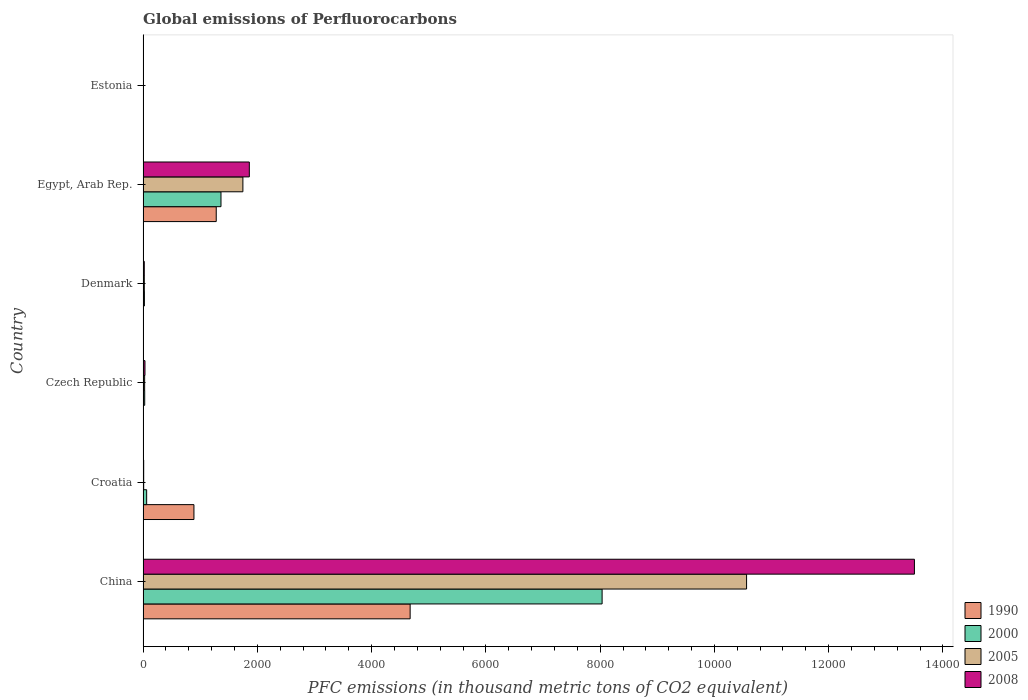How many different coloured bars are there?
Provide a short and direct response. 4. How many groups of bars are there?
Your answer should be compact. 6. Are the number of bars on each tick of the Y-axis equal?
Provide a succinct answer. Yes. How many bars are there on the 1st tick from the bottom?
Make the answer very short. 4. What is the label of the 2nd group of bars from the top?
Keep it short and to the point. Egypt, Arab Rep. What is the global emissions of Perfluorocarbons in 2000 in Czech Republic?
Offer a terse response. 28.8. Across all countries, what is the maximum global emissions of Perfluorocarbons in 2008?
Offer a very short reply. 1.35e+04. In which country was the global emissions of Perfluorocarbons in 1990 maximum?
Your response must be concise. China. In which country was the global emissions of Perfluorocarbons in 2005 minimum?
Keep it short and to the point. Estonia. What is the total global emissions of Perfluorocarbons in 1990 in the graph?
Your answer should be compact. 6850.4. What is the difference between the global emissions of Perfluorocarbons in 2000 in Czech Republic and that in Estonia?
Ensure brevity in your answer.  25.3. What is the difference between the global emissions of Perfluorocarbons in 2005 in Croatia and the global emissions of Perfluorocarbons in 2008 in Estonia?
Ensure brevity in your answer.  7.5. What is the average global emissions of Perfluorocarbons in 1990 per country?
Provide a succinct answer. 1141.73. What is the difference between the global emissions of Perfluorocarbons in 2000 and global emissions of Perfluorocarbons in 2005 in China?
Your response must be concise. -2528.4. What is the ratio of the global emissions of Perfluorocarbons in 2008 in China to that in Croatia?
Offer a terse response. 1227.33. Is the global emissions of Perfluorocarbons in 1990 in China less than that in Egypt, Arab Rep.?
Your answer should be compact. No. What is the difference between the highest and the second highest global emissions of Perfluorocarbons in 2008?
Offer a terse response. 1.16e+04. What is the difference between the highest and the lowest global emissions of Perfluorocarbons in 2005?
Your answer should be very brief. 1.06e+04. Is it the case that in every country, the sum of the global emissions of Perfluorocarbons in 2000 and global emissions of Perfluorocarbons in 2008 is greater than the sum of global emissions of Perfluorocarbons in 1990 and global emissions of Perfluorocarbons in 2005?
Provide a short and direct response. No. What does the 3rd bar from the top in Denmark represents?
Your response must be concise. 2000. Are all the bars in the graph horizontal?
Offer a terse response. Yes. How many legend labels are there?
Make the answer very short. 4. What is the title of the graph?
Your response must be concise. Global emissions of Perfluorocarbons. What is the label or title of the X-axis?
Your response must be concise. PFC emissions (in thousand metric tons of CO2 equivalent). What is the label or title of the Y-axis?
Offer a very short reply. Country. What is the PFC emissions (in thousand metric tons of CO2 equivalent) of 1990 in China?
Your response must be concise. 4674.5. What is the PFC emissions (in thousand metric tons of CO2 equivalent) of 2000 in China?
Provide a short and direct response. 8034.4. What is the PFC emissions (in thousand metric tons of CO2 equivalent) of 2005 in China?
Offer a terse response. 1.06e+04. What is the PFC emissions (in thousand metric tons of CO2 equivalent) of 2008 in China?
Your answer should be very brief. 1.35e+04. What is the PFC emissions (in thousand metric tons of CO2 equivalent) of 1990 in Croatia?
Your response must be concise. 890.4. What is the PFC emissions (in thousand metric tons of CO2 equivalent) of 2005 in Croatia?
Offer a terse response. 10.9. What is the PFC emissions (in thousand metric tons of CO2 equivalent) in 2008 in Croatia?
Offer a terse response. 11. What is the PFC emissions (in thousand metric tons of CO2 equivalent) in 2000 in Czech Republic?
Keep it short and to the point. 28.8. What is the PFC emissions (in thousand metric tons of CO2 equivalent) in 2005 in Czech Republic?
Give a very brief answer. 27.5. What is the PFC emissions (in thousand metric tons of CO2 equivalent) of 2008 in Czech Republic?
Offer a very short reply. 33.3. What is the PFC emissions (in thousand metric tons of CO2 equivalent) of 1990 in Denmark?
Ensure brevity in your answer.  1.4. What is the PFC emissions (in thousand metric tons of CO2 equivalent) of 2000 in Denmark?
Your answer should be compact. 23.4. What is the PFC emissions (in thousand metric tons of CO2 equivalent) in 2008 in Denmark?
Provide a short and direct response. 21.4. What is the PFC emissions (in thousand metric tons of CO2 equivalent) in 1990 in Egypt, Arab Rep.?
Offer a very short reply. 1280.8. What is the PFC emissions (in thousand metric tons of CO2 equivalent) of 2000 in Egypt, Arab Rep.?
Offer a very short reply. 1363.8. What is the PFC emissions (in thousand metric tons of CO2 equivalent) in 2005 in Egypt, Arab Rep.?
Keep it short and to the point. 1747.1. What is the PFC emissions (in thousand metric tons of CO2 equivalent) of 2008 in Egypt, Arab Rep.?
Give a very brief answer. 1859.8. What is the PFC emissions (in thousand metric tons of CO2 equivalent) of 2008 in Estonia?
Your answer should be compact. 3.4. Across all countries, what is the maximum PFC emissions (in thousand metric tons of CO2 equivalent) of 1990?
Offer a very short reply. 4674.5. Across all countries, what is the maximum PFC emissions (in thousand metric tons of CO2 equivalent) in 2000?
Your answer should be very brief. 8034.4. Across all countries, what is the maximum PFC emissions (in thousand metric tons of CO2 equivalent) in 2005?
Keep it short and to the point. 1.06e+04. Across all countries, what is the maximum PFC emissions (in thousand metric tons of CO2 equivalent) of 2008?
Keep it short and to the point. 1.35e+04. Across all countries, what is the minimum PFC emissions (in thousand metric tons of CO2 equivalent) of 1990?
Provide a succinct answer. 0.5. Across all countries, what is the minimum PFC emissions (in thousand metric tons of CO2 equivalent) in 2000?
Make the answer very short. 3.5. Across all countries, what is the minimum PFC emissions (in thousand metric tons of CO2 equivalent) in 2005?
Your response must be concise. 3.4. Across all countries, what is the minimum PFC emissions (in thousand metric tons of CO2 equivalent) of 2008?
Provide a succinct answer. 3.4. What is the total PFC emissions (in thousand metric tons of CO2 equivalent) of 1990 in the graph?
Keep it short and to the point. 6850.4. What is the total PFC emissions (in thousand metric tons of CO2 equivalent) in 2000 in the graph?
Make the answer very short. 9516.9. What is the total PFC emissions (in thousand metric tons of CO2 equivalent) of 2005 in the graph?
Keep it short and to the point. 1.24e+04. What is the total PFC emissions (in thousand metric tons of CO2 equivalent) in 2008 in the graph?
Provide a short and direct response. 1.54e+04. What is the difference between the PFC emissions (in thousand metric tons of CO2 equivalent) in 1990 in China and that in Croatia?
Ensure brevity in your answer.  3784.1. What is the difference between the PFC emissions (in thousand metric tons of CO2 equivalent) in 2000 in China and that in Croatia?
Keep it short and to the point. 7971.4. What is the difference between the PFC emissions (in thousand metric tons of CO2 equivalent) of 2005 in China and that in Croatia?
Offer a terse response. 1.06e+04. What is the difference between the PFC emissions (in thousand metric tons of CO2 equivalent) of 2008 in China and that in Croatia?
Ensure brevity in your answer.  1.35e+04. What is the difference between the PFC emissions (in thousand metric tons of CO2 equivalent) of 1990 in China and that in Czech Republic?
Offer a terse response. 4671.7. What is the difference between the PFC emissions (in thousand metric tons of CO2 equivalent) in 2000 in China and that in Czech Republic?
Provide a succinct answer. 8005.6. What is the difference between the PFC emissions (in thousand metric tons of CO2 equivalent) of 2005 in China and that in Czech Republic?
Your answer should be compact. 1.05e+04. What is the difference between the PFC emissions (in thousand metric tons of CO2 equivalent) of 2008 in China and that in Czech Republic?
Make the answer very short. 1.35e+04. What is the difference between the PFC emissions (in thousand metric tons of CO2 equivalent) in 1990 in China and that in Denmark?
Provide a short and direct response. 4673.1. What is the difference between the PFC emissions (in thousand metric tons of CO2 equivalent) in 2000 in China and that in Denmark?
Your answer should be compact. 8011. What is the difference between the PFC emissions (in thousand metric tons of CO2 equivalent) in 2005 in China and that in Denmark?
Make the answer very short. 1.05e+04. What is the difference between the PFC emissions (in thousand metric tons of CO2 equivalent) in 2008 in China and that in Denmark?
Your response must be concise. 1.35e+04. What is the difference between the PFC emissions (in thousand metric tons of CO2 equivalent) of 1990 in China and that in Egypt, Arab Rep.?
Your answer should be very brief. 3393.7. What is the difference between the PFC emissions (in thousand metric tons of CO2 equivalent) of 2000 in China and that in Egypt, Arab Rep.?
Give a very brief answer. 6670.6. What is the difference between the PFC emissions (in thousand metric tons of CO2 equivalent) of 2005 in China and that in Egypt, Arab Rep.?
Keep it short and to the point. 8815.7. What is the difference between the PFC emissions (in thousand metric tons of CO2 equivalent) in 2008 in China and that in Egypt, Arab Rep.?
Make the answer very short. 1.16e+04. What is the difference between the PFC emissions (in thousand metric tons of CO2 equivalent) in 1990 in China and that in Estonia?
Your response must be concise. 4674. What is the difference between the PFC emissions (in thousand metric tons of CO2 equivalent) of 2000 in China and that in Estonia?
Provide a short and direct response. 8030.9. What is the difference between the PFC emissions (in thousand metric tons of CO2 equivalent) of 2005 in China and that in Estonia?
Offer a terse response. 1.06e+04. What is the difference between the PFC emissions (in thousand metric tons of CO2 equivalent) in 2008 in China and that in Estonia?
Your response must be concise. 1.35e+04. What is the difference between the PFC emissions (in thousand metric tons of CO2 equivalent) of 1990 in Croatia and that in Czech Republic?
Your answer should be very brief. 887.6. What is the difference between the PFC emissions (in thousand metric tons of CO2 equivalent) of 2000 in Croatia and that in Czech Republic?
Make the answer very short. 34.2. What is the difference between the PFC emissions (in thousand metric tons of CO2 equivalent) in 2005 in Croatia and that in Czech Republic?
Provide a succinct answer. -16.6. What is the difference between the PFC emissions (in thousand metric tons of CO2 equivalent) of 2008 in Croatia and that in Czech Republic?
Provide a short and direct response. -22.3. What is the difference between the PFC emissions (in thousand metric tons of CO2 equivalent) of 1990 in Croatia and that in Denmark?
Offer a very short reply. 889. What is the difference between the PFC emissions (in thousand metric tons of CO2 equivalent) of 2000 in Croatia and that in Denmark?
Provide a succinct answer. 39.6. What is the difference between the PFC emissions (in thousand metric tons of CO2 equivalent) of 1990 in Croatia and that in Egypt, Arab Rep.?
Your answer should be compact. -390.4. What is the difference between the PFC emissions (in thousand metric tons of CO2 equivalent) in 2000 in Croatia and that in Egypt, Arab Rep.?
Offer a very short reply. -1300.8. What is the difference between the PFC emissions (in thousand metric tons of CO2 equivalent) in 2005 in Croatia and that in Egypt, Arab Rep.?
Offer a terse response. -1736.2. What is the difference between the PFC emissions (in thousand metric tons of CO2 equivalent) in 2008 in Croatia and that in Egypt, Arab Rep.?
Make the answer very short. -1848.8. What is the difference between the PFC emissions (in thousand metric tons of CO2 equivalent) of 1990 in Croatia and that in Estonia?
Your answer should be very brief. 889.9. What is the difference between the PFC emissions (in thousand metric tons of CO2 equivalent) in 2000 in Croatia and that in Estonia?
Your answer should be compact. 59.5. What is the difference between the PFC emissions (in thousand metric tons of CO2 equivalent) of 2000 in Czech Republic and that in Denmark?
Keep it short and to the point. 5.4. What is the difference between the PFC emissions (in thousand metric tons of CO2 equivalent) of 2005 in Czech Republic and that in Denmark?
Your response must be concise. 6. What is the difference between the PFC emissions (in thousand metric tons of CO2 equivalent) in 2008 in Czech Republic and that in Denmark?
Offer a very short reply. 11.9. What is the difference between the PFC emissions (in thousand metric tons of CO2 equivalent) of 1990 in Czech Republic and that in Egypt, Arab Rep.?
Offer a terse response. -1278. What is the difference between the PFC emissions (in thousand metric tons of CO2 equivalent) in 2000 in Czech Republic and that in Egypt, Arab Rep.?
Your answer should be compact. -1335. What is the difference between the PFC emissions (in thousand metric tons of CO2 equivalent) in 2005 in Czech Republic and that in Egypt, Arab Rep.?
Ensure brevity in your answer.  -1719.6. What is the difference between the PFC emissions (in thousand metric tons of CO2 equivalent) in 2008 in Czech Republic and that in Egypt, Arab Rep.?
Ensure brevity in your answer.  -1826.5. What is the difference between the PFC emissions (in thousand metric tons of CO2 equivalent) in 1990 in Czech Republic and that in Estonia?
Your answer should be compact. 2.3. What is the difference between the PFC emissions (in thousand metric tons of CO2 equivalent) in 2000 in Czech Republic and that in Estonia?
Give a very brief answer. 25.3. What is the difference between the PFC emissions (in thousand metric tons of CO2 equivalent) in 2005 in Czech Republic and that in Estonia?
Provide a succinct answer. 24.1. What is the difference between the PFC emissions (in thousand metric tons of CO2 equivalent) in 2008 in Czech Republic and that in Estonia?
Offer a terse response. 29.9. What is the difference between the PFC emissions (in thousand metric tons of CO2 equivalent) in 1990 in Denmark and that in Egypt, Arab Rep.?
Provide a short and direct response. -1279.4. What is the difference between the PFC emissions (in thousand metric tons of CO2 equivalent) in 2000 in Denmark and that in Egypt, Arab Rep.?
Keep it short and to the point. -1340.4. What is the difference between the PFC emissions (in thousand metric tons of CO2 equivalent) in 2005 in Denmark and that in Egypt, Arab Rep.?
Your answer should be compact. -1725.6. What is the difference between the PFC emissions (in thousand metric tons of CO2 equivalent) in 2008 in Denmark and that in Egypt, Arab Rep.?
Make the answer very short. -1838.4. What is the difference between the PFC emissions (in thousand metric tons of CO2 equivalent) of 2005 in Denmark and that in Estonia?
Give a very brief answer. 18.1. What is the difference between the PFC emissions (in thousand metric tons of CO2 equivalent) in 1990 in Egypt, Arab Rep. and that in Estonia?
Provide a succinct answer. 1280.3. What is the difference between the PFC emissions (in thousand metric tons of CO2 equivalent) of 2000 in Egypt, Arab Rep. and that in Estonia?
Offer a very short reply. 1360.3. What is the difference between the PFC emissions (in thousand metric tons of CO2 equivalent) of 2005 in Egypt, Arab Rep. and that in Estonia?
Provide a succinct answer. 1743.7. What is the difference between the PFC emissions (in thousand metric tons of CO2 equivalent) in 2008 in Egypt, Arab Rep. and that in Estonia?
Ensure brevity in your answer.  1856.4. What is the difference between the PFC emissions (in thousand metric tons of CO2 equivalent) in 1990 in China and the PFC emissions (in thousand metric tons of CO2 equivalent) in 2000 in Croatia?
Offer a very short reply. 4611.5. What is the difference between the PFC emissions (in thousand metric tons of CO2 equivalent) in 1990 in China and the PFC emissions (in thousand metric tons of CO2 equivalent) in 2005 in Croatia?
Your response must be concise. 4663.6. What is the difference between the PFC emissions (in thousand metric tons of CO2 equivalent) of 1990 in China and the PFC emissions (in thousand metric tons of CO2 equivalent) of 2008 in Croatia?
Offer a terse response. 4663.5. What is the difference between the PFC emissions (in thousand metric tons of CO2 equivalent) in 2000 in China and the PFC emissions (in thousand metric tons of CO2 equivalent) in 2005 in Croatia?
Offer a very short reply. 8023.5. What is the difference between the PFC emissions (in thousand metric tons of CO2 equivalent) of 2000 in China and the PFC emissions (in thousand metric tons of CO2 equivalent) of 2008 in Croatia?
Provide a succinct answer. 8023.4. What is the difference between the PFC emissions (in thousand metric tons of CO2 equivalent) of 2005 in China and the PFC emissions (in thousand metric tons of CO2 equivalent) of 2008 in Croatia?
Your answer should be very brief. 1.06e+04. What is the difference between the PFC emissions (in thousand metric tons of CO2 equivalent) in 1990 in China and the PFC emissions (in thousand metric tons of CO2 equivalent) in 2000 in Czech Republic?
Your answer should be compact. 4645.7. What is the difference between the PFC emissions (in thousand metric tons of CO2 equivalent) in 1990 in China and the PFC emissions (in thousand metric tons of CO2 equivalent) in 2005 in Czech Republic?
Your response must be concise. 4647. What is the difference between the PFC emissions (in thousand metric tons of CO2 equivalent) of 1990 in China and the PFC emissions (in thousand metric tons of CO2 equivalent) of 2008 in Czech Republic?
Your answer should be very brief. 4641.2. What is the difference between the PFC emissions (in thousand metric tons of CO2 equivalent) of 2000 in China and the PFC emissions (in thousand metric tons of CO2 equivalent) of 2005 in Czech Republic?
Offer a very short reply. 8006.9. What is the difference between the PFC emissions (in thousand metric tons of CO2 equivalent) of 2000 in China and the PFC emissions (in thousand metric tons of CO2 equivalent) of 2008 in Czech Republic?
Ensure brevity in your answer.  8001.1. What is the difference between the PFC emissions (in thousand metric tons of CO2 equivalent) in 2005 in China and the PFC emissions (in thousand metric tons of CO2 equivalent) in 2008 in Czech Republic?
Ensure brevity in your answer.  1.05e+04. What is the difference between the PFC emissions (in thousand metric tons of CO2 equivalent) in 1990 in China and the PFC emissions (in thousand metric tons of CO2 equivalent) in 2000 in Denmark?
Keep it short and to the point. 4651.1. What is the difference between the PFC emissions (in thousand metric tons of CO2 equivalent) in 1990 in China and the PFC emissions (in thousand metric tons of CO2 equivalent) in 2005 in Denmark?
Provide a succinct answer. 4653. What is the difference between the PFC emissions (in thousand metric tons of CO2 equivalent) in 1990 in China and the PFC emissions (in thousand metric tons of CO2 equivalent) in 2008 in Denmark?
Your answer should be very brief. 4653.1. What is the difference between the PFC emissions (in thousand metric tons of CO2 equivalent) in 2000 in China and the PFC emissions (in thousand metric tons of CO2 equivalent) in 2005 in Denmark?
Ensure brevity in your answer.  8012.9. What is the difference between the PFC emissions (in thousand metric tons of CO2 equivalent) of 2000 in China and the PFC emissions (in thousand metric tons of CO2 equivalent) of 2008 in Denmark?
Provide a succinct answer. 8013. What is the difference between the PFC emissions (in thousand metric tons of CO2 equivalent) of 2005 in China and the PFC emissions (in thousand metric tons of CO2 equivalent) of 2008 in Denmark?
Keep it short and to the point. 1.05e+04. What is the difference between the PFC emissions (in thousand metric tons of CO2 equivalent) in 1990 in China and the PFC emissions (in thousand metric tons of CO2 equivalent) in 2000 in Egypt, Arab Rep.?
Offer a terse response. 3310.7. What is the difference between the PFC emissions (in thousand metric tons of CO2 equivalent) in 1990 in China and the PFC emissions (in thousand metric tons of CO2 equivalent) in 2005 in Egypt, Arab Rep.?
Ensure brevity in your answer.  2927.4. What is the difference between the PFC emissions (in thousand metric tons of CO2 equivalent) in 1990 in China and the PFC emissions (in thousand metric tons of CO2 equivalent) in 2008 in Egypt, Arab Rep.?
Provide a succinct answer. 2814.7. What is the difference between the PFC emissions (in thousand metric tons of CO2 equivalent) of 2000 in China and the PFC emissions (in thousand metric tons of CO2 equivalent) of 2005 in Egypt, Arab Rep.?
Provide a short and direct response. 6287.3. What is the difference between the PFC emissions (in thousand metric tons of CO2 equivalent) in 2000 in China and the PFC emissions (in thousand metric tons of CO2 equivalent) in 2008 in Egypt, Arab Rep.?
Provide a short and direct response. 6174.6. What is the difference between the PFC emissions (in thousand metric tons of CO2 equivalent) in 2005 in China and the PFC emissions (in thousand metric tons of CO2 equivalent) in 2008 in Egypt, Arab Rep.?
Offer a terse response. 8703. What is the difference between the PFC emissions (in thousand metric tons of CO2 equivalent) in 1990 in China and the PFC emissions (in thousand metric tons of CO2 equivalent) in 2000 in Estonia?
Provide a short and direct response. 4671. What is the difference between the PFC emissions (in thousand metric tons of CO2 equivalent) of 1990 in China and the PFC emissions (in thousand metric tons of CO2 equivalent) of 2005 in Estonia?
Make the answer very short. 4671.1. What is the difference between the PFC emissions (in thousand metric tons of CO2 equivalent) of 1990 in China and the PFC emissions (in thousand metric tons of CO2 equivalent) of 2008 in Estonia?
Your answer should be compact. 4671.1. What is the difference between the PFC emissions (in thousand metric tons of CO2 equivalent) of 2000 in China and the PFC emissions (in thousand metric tons of CO2 equivalent) of 2005 in Estonia?
Keep it short and to the point. 8031. What is the difference between the PFC emissions (in thousand metric tons of CO2 equivalent) of 2000 in China and the PFC emissions (in thousand metric tons of CO2 equivalent) of 2008 in Estonia?
Make the answer very short. 8031. What is the difference between the PFC emissions (in thousand metric tons of CO2 equivalent) of 2005 in China and the PFC emissions (in thousand metric tons of CO2 equivalent) of 2008 in Estonia?
Keep it short and to the point. 1.06e+04. What is the difference between the PFC emissions (in thousand metric tons of CO2 equivalent) in 1990 in Croatia and the PFC emissions (in thousand metric tons of CO2 equivalent) in 2000 in Czech Republic?
Keep it short and to the point. 861.6. What is the difference between the PFC emissions (in thousand metric tons of CO2 equivalent) of 1990 in Croatia and the PFC emissions (in thousand metric tons of CO2 equivalent) of 2005 in Czech Republic?
Your answer should be compact. 862.9. What is the difference between the PFC emissions (in thousand metric tons of CO2 equivalent) in 1990 in Croatia and the PFC emissions (in thousand metric tons of CO2 equivalent) in 2008 in Czech Republic?
Provide a short and direct response. 857.1. What is the difference between the PFC emissions (in thousand metric tons of CO2 equivalent) in 2000 in Croatia and the PFC emissions (in thousand metric tons of CO2 equivalent) in 2005 in Czech Republic?
Offer a terse response. 35.5. What is the difference between the PFC emissions (in thousand metric tons of CO2 equivalent) in 2000 in Croatia and the PFC emissions (in thousand metric tons of CO2 equivalent) in 2008 in Czech Republic?
Offer a very short reply. 29.7. What is the difference between the PFC emissions (in thousand metric tons of CO2 equivalent) of 2005 in Croatia and the PFC emissions (in thousand metric tons of CO2 equivalent) of 2008 in Czech Republic?
Give a very brief answer. -22.4. What is the difference between the PFC emissions (in thousand metric tons of CO2 equivalent) in 1990 in Croatia and the PFC emissions (in thousand metric tons of CO2 equivalent) in 2000 in Denmark?
Keep it short and to the point. 867. What is the difference between the PFC emissions (in thousand metric tons of CO2 equivalent) in 1990 in Croatia and the PFC emissions (in thousand metric tons of CO2 equivalent) in 2005 in Denmark?
Make the answer very short. 868.9. What is the difference between the PFC emissions (in thousand metric tons of CO2 equivalent) in 1990 in Croatia and the PFC emissions (in thousand metric tons of CO2 equivalent) in 2008 in Denmark?
Offer a very short reply. 869. What is the difference between the PFC emissions (in thousand metric tons of CO2 equivalent) of 2000 in Croatia and the PFC emissions (in thousand metric tons of CO2 equivalent) of 2005 in Denmark?
Your answer should be very brief. 41.5. What is the difference between the PFC emissions (in thousand metric tons of CO2 equivalent) in 2000 in Croatia and the PFC emissions (in thousand metric tons of CO2 equivalent) in 2008 in Denmark?
Provide a succinct answer. 41.6. What is the difference between the PFC emissions (in thousand metric tons of CO2 equivalent) of 1990 in Croatia and the PFC emissions (in thousand metric tons of CO2 equivalent) of 2000 in Egypt, Arab Rep.?
Make the answer very short. -473.4. What is the difference between the PFC emissions (in thousand metric tons of CO2 equivalent) in 1990 in Croatia and the PFC emissions (in thousand metric tons of CO2 equivalent) in 2005 in Egypt, Arab Rep.?
Offer a very short reply. -856.7. What is the difference between the PFC emissions (in thousand metric tons of CO2 equivalent) of 1990 in Croatia and the PFC emissions (in thousand metric tons of CO2 equivalent) of 2008 in Egypt, Arab Rep.?
Ensure brevity in your answer.  -969.4. What is the difference between the PFC emissions (in thousand metric tons of CO2 equivalent) in 2000 in Croatia and the PFC emissions (in thousand metric tons of CO2 equivalent) in 2005 in Egypt, Arab Rep.?
Ensure brevity in your answer.  -1684.1. What is the difference between the PFC emissions (in thousand metric tons of CO2 equivalent) of 2000 in Croatia and the PFC emissions (in thousand metric tons of CO2 equivalent) of 2008 in Egypt, Arab Rep.?
Provide a succinct answer. -1796.8. What is the difference between the PFC emissions (in thousand metric tons of CO2 equivalent) of 2005 in Croatia and the PFC emissions (in thousand metric tons of CO2 equivalent) of 2008 in Egypt, Arab Rep.?
Offer a very short reply. -1848.9. What is the difference between the PFC emissions (in thousand metric tons of CO2 equivalent) of 1990 in Croatia and the PFC emissions (in thousand metric tons of CO2 equivalent) of 2000 in Estonia?
Ensure brevity in your answer.  886.9. What is the difference between the PFC emissions (in thousand metric tons of CO2 equivalent) in 1990 in Croatia and the PFC emissions (in thousand metric tons of CO2 equivalent) in 2005 in Estonia?
Give a very brief answer. 887. What is the difference between the PFC emissions (in thousand metric tons of CO2 equivalent) in 1990 in Croatia and the PFC emissions (in thousand metric tons of CO2 equivalent) in 2008 in Estonia?
Give a very brief answer. 887. What is the difference between the PFC emissions (in thousand metric tons of CO2 equivalent) of 2000 in Croatia and the PFC emissions (in thousand metric tons of CO2 equivalent) of 2005 in Estonia?
Keep it short and to the point. 59.6. What is the difference between the PFC emissions (in thousand metric tons of CO2 equivalent) in 2000 in Croatia and the PFC emissions (in thousand metric tons of CO2 equivalent) in 2008 in Estonia?
Provide a short and direct response. 59.6. What is the difference between the PFC emissions (in thousand metric tons of CO2 equivalent) of 1990 in Czech Republic and the PFC emissions (in thousand metric tons of CO2 equivalent) of 2000 in Denmark?
Give a very brief answer. -20.6. What is the difference between the PFC emissions (in thousand metric tons of CO2 equivalent) of 1990 in Czech Republic and the PFC emissions (in thousand metric tons of CO2 equivalent) of 2005 in Denmark?
Give a very brief answer. -18.7. What is the difference between the PFC emissions (in thousand metric tons of CO2 equivalent) of 1990 in Czech Republic and the PFC emissions (in thousand metric tons of CO2 equivalent) of 2008 in Denmark?
Offer a terse response. -18.6. What is the difference between the PFC emissions (in thousand metric tons of CO2 equivalent) of 2000 in Czech Republic and the PFC emissions (in thousand metric tons of CO2 equivalent) of 2008 in Denmark?
Give a very brief answer. 7.4. What is the difference between the PFC emissions (in thousand metric tons of CO2 equivalent) of 2005 in Czech Republic and the PFC emissions (in thousand metric tons of CO2 equivalent) of 2008 in Denmark?
Keep it short and to the point. 6.1. What is the difference between the PFC emissions (in thousand metric tons of CO2 equivalent) in 1990 in Czech Republic and the PFC emissions (in thousand metric tons of CO2 equivalent) in 2000 in Egypt, Arab Rep.?
Offer a terse response. -1361. What is the difference between the PFC emissions (in thousand metric tons of CO2 equivalent) in 1990 in Czech Republic and the PFC emissions (in thousand metric tons of CO2 equivalent) in 2005 in Egypt, Arab Rep.?
Your answer should be compact. -1744.3. What is the difference between the PFC emissions (in thousand metric tons of CO2 equivalent) in 1990 in Czech Republic and the PFC emissions (in thousand metric tons of CO2 equivalent) in 2008 in Egypt, Arab Rep.?
Your answer should be very brief. -1857. What is the difference between the PFC emissions (in thousand metric tons of CO2 equivalent) of 2000 in Czech Republic and the PFC emissions (in thousand metric tons of CO2 equivalent) of 2005 in Egypt, Arab Rep.?
Ensure brevity in your answer.  -1718.3. What is the difference between the PFC emissions (in thousand metric tons of CO2 equivalent) in 2000 in Czech Republic and the PFC emissions (in thousand metric tons of CO2 equivalent) in 2008 in Egypt, Arab Rep.?
Provide a short and direct response. -1831. What is the difference between the PFC emissions (in thousand metric tons of CO2 equivalent) in 2005 in Czech Republic and the PFC emissions (in thousand metric tons of CO2 equivalent) in 2008 in Egypt, Arab Rep.?
Keep it short and to the point. -1832.3. What is the difference between the PFC emissions (in thousand metric tons of CO2 equivalent) in 1990 in Czech Republic and the PFC emissions (in thousand metric tons of CO2 equivalent) in 2005 in Estonia?
Give a very brief answer. -0.6. What is the difference between the PFC emissions (in thousand metric tons of CO2 equivalent) in 1990 in Czech Republic and the PFC emissions (in thousand metric tons of CO2 equivalent) in 2008 in Estonia?
Give a very brief answer. -0.6. What is the difference between the PFC emissions (in thousand metric tons of CO2 equivalent) in 2000 in Czech Republic and the PFC emissions (in thousand metric tons of CO2 equivalent) in 2005 in Estonia?
Make the answer very short. 25.4. What is the difference between the PFC emissions (in thousand metric tons of CO2 equivalent) in 2000 in Czech Republic and the PFC emissions (in thousand metric tons of CO2 equivalent) in 2008 in Estonia?
Your answer should be very brief. 25.4. What is the difference between the PFC emissions (in thousand metric tons of CO2 equivalent) of 2005 in Czech Republic and the PFC emissions (in thousand metric tons of CO2 equivalent) of 2008 in Estonia?
Your answer should be very brief. 24.1. What is the difference between the PFC emissions (in thousand metric tons of CO2 equivalent) of 1990 in Denmark and the PFC emissions (in thousand metric tons of CO2 equivalent) of 2000 in Egypt, Arab Rep.?
Make the answer very short. -1362.4. What is the difference between the PFC emissions (in thousand metric tons of CO2 equivalent) in 1990 in Denmark and the PFC emissions (in thousand metric tons of CO2 equivalent) in 2005 in Egypt, Arab Rep.?
Ensure brevity in your answer.  -1745.7. What is the difference between the PFC emissions (in thousand metric tons of CO2 equivalent) of 1990 in Denmark and the PFC emissions (in thousand metric tons of CO2 equivalent) of 2008 in Egypt, Arab Rep.?
Ensure brevity in your answer.  -1858.4. What is the difference between the PFC emissions (in thousand metric tons of CO2 equivalent) in 2000 in Denmark and the PFC emissions (in thousand metric tons of CO2 equivalent) in 2005 in Egypt, Arab Rep.?
Your answer should be very brief. -1723.7. What is the difference between the PFC emissions (in thousand metric tons of CO2 equivalent) of 2000 in Denmark and the PFC emissions (in thousand metric tons of CO2 equivalent) of 2008 in Egypt, Arab Rep.?
Make the answer very short. -1836.4. What is the difference between the PFC emissions (in thousand metric tons of CO2 equivalent) in 2005 in Denmark and the PFC emissions (in thousand metric tons of CO2 equivalent) in 2008 in Egypt, Arab Rep.?
Keep it short and to the point. -1838.3. What is the difference between the PFC emissions (in thousand metric tons of CO2 equivalent) of 2000 in Denmark and the PFC emissions (in thousand metric tons of CO2 equivalent) of 2005 in Estonia?
Keep it short and to the point. 20. What is the difference between the PFC emissions (in thousand metric tons of CO2 equivalent) of 2000 in Denmark and the PFC emissions (in thousand metric tons of CO2 equivalent) of 2008 in Estonia?
Give a very brief answer. 20. What is the difference between the PFC emissions (in thousand metric tons of CO2 equivalent) in 1990 in Egypt, Arab Rep. and the PFC emissions (in thousand metric tons of CO2 equivalent) in 2000 in Estonia?
Keep it short and to the point. 1277.3. What is the difference between the PFC emissions (in thousand metric tons of CO2 equivalent) in 1990 in Egypt, Arab Rep. and the PFC emissions (in thousand metric tons of CO2 equivalent) in 2005 in Estonia?
Give a very brief answer. 1277.4. What is the difference between the PFC emissions (in thousand metric tons of CO2 equivalent) of 1990 in Egypt, Arab Rep. and the PFC emissions (in thousand metric tons of CO2 equivalent) of 2008 in Estonia?
Your answer should be very brief. 1277.4. What is the difference between the PFC emissions (in thousand metric tons of CO2 equivalent) in 2000 in Egypt, Arab Rep. and the PFC emissions (in thousand metric tons of CO2 equivalent) in 2005 in Estonia?
Your response must be concise. 1360.4. What is the difference between the PFC emissions (in thousand metric tons of CO2 equivalent) in 2000 in Egypt, Arab Rep. and the PFC emissions (in thousand metric tons of CO2 equivalent) in 2008 in Estonia?
Make the answer very short. 1360.4. What is the difference between the PFC emissions (in thousand metric tons of CO2 equivalent) of 2005 in Egypt, Arab Rep. and the PFC emissions (in thousand metric tons of CO2 equivalent) of 2008 in Estonia?
Offer a terse response. 1743.7. What is the average PFC emissions (in thousand metric tons of CO2 equivalent) of 1990 per country?
Your answer should be compact. 1141.73. What is the average PFC emissions (in thousand metric tons of CO2 equivalent) of 2000 per country?
Your answer should be very brief. 1586.15. What is the average PFC emissions (in thousand metric tons of CO2 equivalent) of 2005 per country?
Make the answer very short. 2062.2. What is the average PFC emissions (in thousand metric tons of CO2 equivalent) of 2008 per country?
Give a very brief answer. 2571.58. What is the difference between the PFC emissions (in thousand metric tons of CO2 equivalent) of 1990 and PFC emissions (in thousand metric tons of CO2 equivalent) of 2000 in China?
Offer a terse response. -3359.9. What is the difference between the PFC emissions (in thousand metric tons of CO2 equivalent) in 1990 and PFC emissions (in thousand metric tons of CO2 equivalent) in 2005 in China?
Provide a short and direct response. -5888.3. What is the difference between the PFC emissions (in thousand metric tons of CO2 equivalent) of 1990 and PFC emissions (in thousand metric tons of CO2 equivalent) of 2008 in China?
Your response must be concise. -8826.1. What is the difference between the PFC emissions (in thousand metric tons of CO2 equivalent) in 2000 and PFC emissions (in thousand metric tons of CO2 equivalent) in 2005 in China?
Provide a short and direct response. -2528.4. What is the difference between the PFC emissions (in thousand metric tons of CO2 equivalent) in 2000 and PFC emissions (in thousand metric tons of CO2 equivalent) in 2008 in China?
Keep it short and to the point. -5466.2. What is the difference between the PFC emissions (in thousand metric tons of CO2 equivalent) in 2005 and PFC emissions (in thousand metric tons of CO2 equivalent) in 2008 in China?
Ensure brevity in your answer.  -2937.8. What is the difference between the PFC emissions (in thousand metric tons of CO2 equivalent) in 1990 and PFC emissions (in thousand metric tons of CO2 equivalent) in 2000 in Croatia?
Your response must be concise. 827.4. What is the difference between the PFC emissions (in thousand metric tons of CO2 equivalent) in 1990 and PFC emissions (in thousand metric tons of CO2 equivalent) in 2005 in Croatia?
Provide a short and direct response. 879.5. What is the difference between the PFC emissions (in thousand metric tons of CO2 equivalent) in 1990 and PFC emissions (in thousand metric tons of CO2 equivalent) in 2008 in Croatia?
Provide a succinct answer. 879.4. What is the difference between the PFC emissions (in thousand metric tons of CO2 equivalent) of 2000 and PFC emissions (in thousand metric tons of CO2 equivalent) of 2005 in Croatia?
Offer a very short reply. 52.1. What is the difference between the PFC emissions (in thousand metric tons of CO2 equivalent) of 1990 and PFC emissions (in thousand metric tons of CO2 equivalent) of 2000 in Czech Republic?
Provide a succinct answer. -26. What is the difference between the PFC emissions (in thousand metric tons of CO2 equivalent) of 1990 and PFC emissions (in thousand metric tons of CO2 equivalent) of 2005 in Czech Republic?
Keep it short and to the point. -24.7. What is the difference between the PFC emissions (in thousand metric tons of CO2 equivalent) of 1990 and PFC emissions (in thousand metric tons of CO2 equivalent) of 2008 in Czech Republic?
Offer a terse response. -30.5. What is the difference between the PFC emissions (in thousand metric tons of CO2 equivalent) of 2000 and PFC emissions (in thousand metric tons of CO2 equivalent) of 2005 in Czech Republic?
Provide a short and direct response. 1.3. What is the difference between the PFC emissions (in thousand metric tons of CO2 equivalent) in 1990 and PFC emissions (in thousand metric tons of CO2 equivalent) in 2000 in Denmark?
Provide a short and direct response. -22. What is the difference between the PFC emissions (in thousand metric tons of CO2 equivalent) in 1990 and PFC emissions (in thousand metric tons of CO2 equivalent) in 2005 in Denmark?
Provide a short and direct response. -20.1. What is the difference between the PFC emissions (in thousand metric tons of CO2 equivalent) of 2005 and PFC emissions (in thousand metric tons of CO2 equivalent) of 2008 in Denmark?
Your response must be concise. 0.1. What is the difference between the PFC emissions (in thousand metric tons of CO2 equivalent) in 1990 and PFC emissions (in thousand metric tons of CO2 equivalent) in 2000 in Egypt, Arab Rep.?
Give a very brief answer. -83. What is the difference between the PFC emissions (in thousand metric tons of CO2 equivalent) in 1990 and PFC emissions (in thousand metric tons of CO2 equivalent) in 2005 in Egypt, Arab Rep.?
Ensure brevity in your answer.  -466.3. What is the difference between the PFC emissions (in thousand metric tons of CO2 equivalent) of 1990 and PFC emissions (in thousand metric tons of CO2 equivalent) of 2008 in Egypt, Arab Rep.?
Provide a succinct answer. -579. What is the difference between the PFC emissions (in thousand metric tons of CO2 equivalent) in 2000 and PFC emissions (in thousand metric tons of CO2 equivalent) in 2005 in Egypt, Arab Rep.?
Give a very brief answer. -383.3. What is the difference between the PFC emissions (in thousand metric tons of CO2 equivalent) in 2000 and PFC emissions (in thousand metric tons of CO2 equivalent) in 2008 in Egypt, Arab Rep.?
Your answer should be compact. -496. What is the difference between the PFC emissions (in thousand metric tons of CO2 equivalent) of 2005 and PFC emissions (in thousand metric tons of CO2 equivalent) of 2008 in Egypt, Arab Rep.?
Ensure brevity in your answer.  -112.7. What is the difference between the PFC emissions (in thousand metric tons of CO2 equivalent) in 1990 and PFC emissions (in thousand metric tons of CO2 equivalent) in 2000 in Estonia?
Your response must be concise. -3. What is the difference between the PFC emissions (in thousand metric tons of CO2 equivalent) of 1990 and PFC emissions (in thousand metric tons of CO2 equivalent) of 2005 in Estonia?
Provide a succinct answer. -2.9. What is the difference between the PFC emissions (in thousand metric tons of CO2 equivalent) in 1990 and PFC emissions (in thousand metric tons of CO2 equivalent) in 2008 in Estonia?
Your response must be concise. -2.9. What is the difference between the PFC emissions (in thousand metric tons of CO2 equivalent) of 2000 and PFC emissions (in thousand metric tons of CO2 equivalent) of 2005 in Estonia?
Keep it short and to the point. 0.1. What is the ratio of the PFC emissions (in thousand metric tons of CO2 equivalent) of 1990 in China to that in Croatia?
Keep it short and to the point. 5.25. What is the ratio of the PFC emissions (in thousand metric tons of CO2 equivalent) of 2000 in China to that in Croatia?
Ensure brevity in your answer.  127.53. What is the ratio of the PFC emissions (in thousand metric tons of CO2 equivalent) of 2005 in China to that in Croatia?
Make the answer very short. 969.06. What is the ratio of the PFC emissions (in thousand metric tons of CO2 equivalent) of 2008 in China to that in Croatia?
Give a very brief answer. 1227.33. What is the ratio of the PFC emissions (in thousand metric tons of CO2 equivalent) in 1990 in China to that in Czech Republic?
Provide a succinct answer. 1669.46. What is the ratio of the PFC emissions (in thousand metric tons of CO2 equivalent) of 2000 in China to that in Czech Republic?
Keep it short and to the point. 278.97. What is the ratio of the PFC emissions (in thousand metric tons of CO2 equivalent) of 2005 in China to that in Czech Republic?
Your response must be concise. 384.1. What is the ratio of the PFC emissions (in thousand metric tons of CO2 equivalent) in 2008 in China to that in Czech Republic?
Offer a very short reply. 405.42. What is the ratio of the PFC emissions (in thousand metric tons of CO2 equivalent) in 1990 in China to that in Denmark?
Your response must be concise. 3338.93. What is the ratio of the PFC emissions (in thousand metric tons of CO2 equivalent) of 2000 in China to that in Denmark?
Provide a succinct answer. 343.35. What is the ratio of the PFC emissions (in thousand metric tons of CO2 equivalent) of 2005 in China to that in Denmark?
Ensure brevity in your answer.  491.29. What is the ratio of the PFC emissions (in thousand metric tons of CO2 equivalent) in 2008 in China to that in Denmark?
Your answer should be compact. 630.87. What is the ratio of the PFC emissions (in thousand metric tons of CO2 equivalent) of 1990 in China to that in Egypt, Arab Rep.?
Make the answer very short. 3.65. What is the ratio of the PFC emissions (in thousand metric tons of CO2 equivalent) of 2000 in China to that in Egypt, Arab Rep.?
Your response must be concise. 5.89. What is the ratio of the PFC emissions (in thousand metric tons of CO2 equivalent) of 2005 in China to that in Egypt, Arab Rep.?
Your response must be concise. 6.05. What is the ratio of the PFC emissions (in thousand metric tons of CO2 equivalent) in 2008 in China to that in Egypt, Arab Rep.?
Provide a short and direct response. 7.26. What is the ratio of the PFC emissions (in thousand metric tons of CO2 equivalent) in 1990 in China to that in Estonia?
Provide a short and direct response. 9349. What is the ratio of the PFC emissions (in thousand metric tons of CO2 equivalent) in 2000 in China to that in Estonia?
Make the answer very short. 2295.54. What is the ratio of the PFC emissions (in thousand metric tons of CO2 equivalent) of 2005 in China to that in Estonia?
Provide a short and direct response. 3106.71. What is the ratio of the PFC emissions (in thousand metric tons of CO2 equivalent) of 2008 in China to that in Estonia?
Offer a terse response. 3970.76. What is the ratio of the PFC emissions (in thousand metric tons of CO2 equivalent) of 1990 in Croatia to that in Czech Republic?
Your answer should be very brief. 318. What is the ratio of the PFC emissions (in thousand metric tons of CO2 equivalent) in 2000 in Croatia to that in Czech Republic?
Make the answer very short. 2.19. What is the ratio of the PFC emissions (in thousand metric tons of CO2 equivalent) in 2005 in Croatia to that in Czech Republic?
Make the answer very short. 0.4. What is the ratio of the PFC emissions (in thousand metric tons of CO2 equivalent) in 2008 in Croatia to that in Czech Republic?
Offer a terse response. 0.33. What is the ratio of the PFC emissions (in thousand metric tons of CO2 equivalent) of 1990 in Croatia to that in Denmark?
Your answer should be very brief. 636. What is the ratio of the PFC emissions (in thousand metric tons of CO2 equivalent) of 2000 in Croatia to that in Denmark?
Ensure brevity in your answer.  2.69. What is the ratio of the PFC emissions (in thousand metric tons of CO2 equivalent) of 2005 in Croatia to that in Denmark?
Provide a succinct answer. 0.51. What is the ratio of the PFC emissions (in thousand metric tons of CO2 equivalent) in 2008 in Croatia to that in Denmark?
Keep it short and to the point. 0.51. What is the ratio of the PFC emissions (in thousand metric tons of CO2 equivalent) of 1990 in Croatia to that in Egypt, Arab Rep.?
Provide a short and direct response. 0.7. What is the ratio of the PFC emissions (in thousand metric tons of CO2 equivalent) in 2000 in Croatia to that in Egypt, Arab Rep.?
Ensure brevity in your answer.  0.05. What is the ratio of the PFC emissions (in thousand metric tons of CO2 equivalent) in 2005 in Croatia to that in Egypt, Arab Rep.?
Keep it short and to the point. 0.01. What is the ratio of the PFC emissions (in thousand metric tons of CO2 equivalent) of 2008 in Croatia to that in Egypt, Arab Rep.?
Keep it short and to the point. 0.01. What is the ratio of the PFC emissions (in thousand metric tons of CO2 equivalent) of 1990 in Croatia to that in Estonia?
Offer a very short reply. 1780.8. What is the ratio of the PFC emissions (in thousand metric tons of CO2 equivalent) of 2000 in Croatia to that in Estonia?
Ensure brevity in your answer.  18. What is the ratio of the PFC emissions (in thousand metric tons of CO2 equivalent) of 2005 in Croatia to that in Estonia?
Make the answer very short. 3.21. What is the ratio of the PFC emissions (in thousand metric tons of CO2 equivalent) in 2008 in Croatia to that in Estonia?
Provide a short and direct response. 3.24. What is the ratio of the PFC emissions (in thousand metric tons of CO2 equivalent) of 1990 in Czech Republic to that in Denmark?
Offer a very short reply. 2. What is the ratio of the PFC emissions (in thousand metric tons of CO2 equivalent) in 2000 in Czech Republic to that in Denmark?
Your answer should be very brief. 1.23. What is the ratio of the PFC emissions (in thousand metric tons of CO2 equivalent) of 2005 in Czech Republic to that in Denmark?
Offer a terse response. 1.28. What is the ratio of the PFC emissions (in thousand metric tons of CO2 equivalent) in 2008 in Czech Republic to that in Denmark?
Keep it short and to the point. 1.56. What is the ratio of the PFC emissions (in thousand metric tons of CO2 equivalent) in 1990 in Czech Republic to that in Egypt, Arab Rep.?
Provide a succinct answer. 0. What is the ratio of the PFC emissions (in thousand metric tons of CO2 equivalent) of 2000 in Czech Republic to that in Egypt, Arab Rep.?
Provide a succinct answer. 0.02. What is the ratio of the PFC emissions (in thousand metric tons of CO2 equivalent) in 2005 in Czech Republic to that in Egypt, Arab Rep.?
Make the answer very short. 0.02. What is the ratio of the PFC emissions (in thousand metric tons of CO2 equivalent) in 2008 in Czech Republic to that in Egypt, Arab Rep.?
Provide a short and direct response. 0.02. What is the ratio of the PFC emissions (in thousand metric tons of CO2 equivalent) in 1990 in Czech Republic to that in Estonia?
Offer a terse response. 5.6. What is the ratio of the PFC emissions (in thousand metric tons of CO2 equivalent) of 2000 in Czech Republic to that in Estonia?
Make the answer very short. 8.23. What is the ratio of the PFC emissions (in thousand metric tons of CO2 equivalent) of 2005 in Czech Republic to that in Estonia?
Offer a very short reply. 8.09. What is the ratio of the PFC emissions (in thousand metric tons of CO2 equivalent) of 2008 in Czech Republic to that in Estonia?
Offer a very short reply. 9.79. What is the ratio of the PFC emissions (in thousand metric tons of CO2 equivalent) in 1990 in Denmark to that in Egypt, Arab Rep.?
Give a very brief answer. 0. What is the ratio of the PFC emissions (in thousand metric tons of CO2 equivalent) in 2000 in Denmark to that in Egypt, Arab Rep.?
Ensure brevity in your answer.  0.02. What is the ratio of the PFC emissions (in thousand metric tons of CO2 equivalent) of 2005 in Denmark to that in Egypt, Arab Rep.?
Make the answer very short. 0.01. What is the ratio of the PFC emissions (in thousand metric tons of CO2 equivalent) in 2008 in Denmark to that in Egypt, Arab Rep.?
Your response must be concise. 0.01. What is the ratio of the PFC emissions (in thousand metric tons of CO2 equivalent) of 2000 in Denmark to that in Estonia?
Offer a very short reply. 6.69. What is the ratio of the PFC emissions (in thousand metric tons of CO2 equivalent) of 2005 in Denmark to that in Estonia?
Your answer should be compact. 6.32. What is the ratio of the PFC emissions (in thousand metric tons of CO2 equivalent) in 2008 in Denmark to that in Estonia?
Your answer should be very brief. 6.29. What is the ratio of the PFC emissions (in thousand metric tons of CO2 equivalent) of 1990 in Egypt, Arab Rep. to that in Estonia?
Offer a terse response. 2561.6. What is the ratio of the PFC emissions (in thousand metric tons of CO2 equivalent) in 2000 in Egypt, Arab Rep. to that in Estonia?
Your response must be concise. 389.66. What is the ratio of the PFC emissions (in thousand metric tons of CO2 equivalent) of 2005 in Egypt, Arab Rep. to that in Estonia?
Provide a short and direct response. 513.85. What is the ratio of the PFC emissions (in thousand metric tons of CO2 equivalent) in 2008 in Egypt, Arab Rep. to that in Estonia?
Offer a very short reply. 547. What is the difference between the highest and the second highest PFC emissions (in thousand metric tons of CO2 equivalent) of 1990?
Ensure brevity in your answer.  3393.7. What is the difference between the highest and the second highest PFC emissions (in thousand metric tons of CO2 equivalent) of 2000?
Make the answer very short. 6670.6. What is the difference between the highest and the second highest PFC emissions (in thousand metric tons of CO2 equivalent) in 2005?
Offer a terse response. 8815.7. What is the difference between the highest and the second highest PFC emissions (in thousand metric tons of CO2 equivalent) in 2008?
Ensure brevity in your answer.  1.16e+04. What is the difference between the highest and the lowest PFC emissions (in thousand metric tons of CO2 equivalent) in 1990?
Your answer should be very brief. 4674. What is the difference between the highest and the lowest PFC emissions (in thousand metric tons of CO2 equivalent) of 2000?
Ensure brevity in your answer.  8030.9. What is the difference between the highest and the lowest PFC emissions (in thousand metric tons of CO2 equivalent) in 2005?
Keep it short and to the point. 1.06e+04. What is the difference between the highest and the lowest PFC emissions (in thousand metric tons of CO2 equivalent) in 2008?
Make the answer very short. 1.35e+04. 